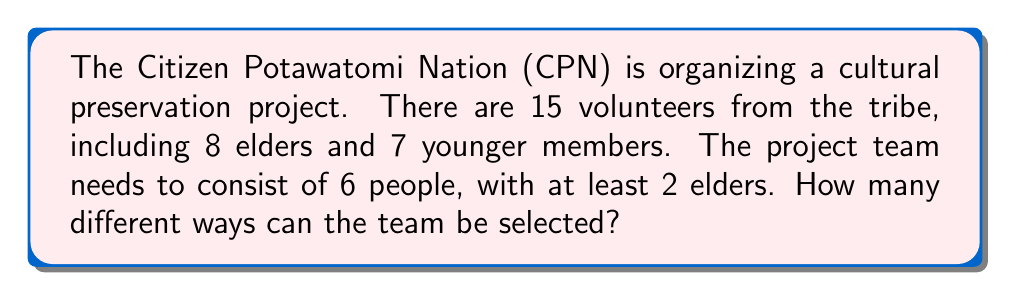Help me with this question. Let's approach this step-by-step using the concept of combinations:

1) First, we need to consider the different ways to select elders:
   - We can select 2, 3, 4, 5, or 6 elders.

2) For each of these cases, we need to fill the remaining spots with younger members.

3) Let's calculate each case:

   a) 2 elders and 4 younger members:
      $\binom{8}{2} \times \binom{7}{4}$

   b) 3 elders and 3 younger members:
      $\binom{8}{3} \times \binom{7}{3}$

   c) 4 elders and 2 younger members:
      $\binom{8}{4} \times \binom{7}{2}$

   d) 5 elders and 1 younger member:
      $\binom{8}{5} \times \binom{7}{1}$

   e) 6 elders and 0 younger members:
      $\binom{8}{6} \times \binom{7}{0}$

4) Now, let's calculate each of these:

   a) $\binom{8}{2} \times \binom{7}{4} = 28 \times 35 = 980$
   b) $\binom{8}{3} \times \binom{7}{3} = 56 \times 35 = 1,960$
   c) $\binom{8}{4} \times \binom{7}{2} = 70 \times 21 = 1,470$
   d) $\binom{8}{5} \times \binom{7}{1} = 56 \times 7 = 392$
   e) $\binom{8}{6} \times \binom{7}{0} = 28 \times 1 = 28$

5) The total number of ways is the sum of all these cases:

   $980 + 1,960 + 1,470 + 392 + 28 = 4,830$

Therefore, there are 4,830 different ways to select the team.
Answer: 4,830 